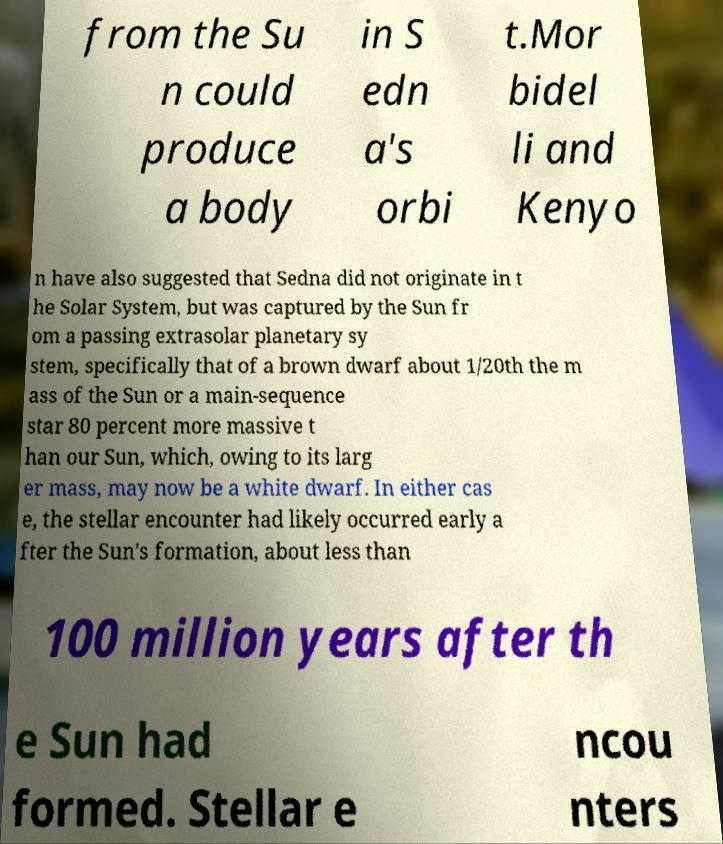Could you assist in decoding the text presented in this image and type it out clearly? from the Su n could produce a body in S edn a's orbi t.Mor bidel li and Kenyo n have also suggested that Sedna did not originate in t he Solar System, but was captured by the Sun fr om a passing extrasolar planetary sy stem, specifically that of a brown dwarf about 1/20th the m ass of the Sun or a main-sequence star 80 percent more massive t han our Sun, which, owing to its larg er mass, may now be a white dwarf. In either cas e, the stellar encounter had likely occurred early a fter the Sun's formation, about less than 100 million years after th e Sun had formed. Stellar e ncou nters 